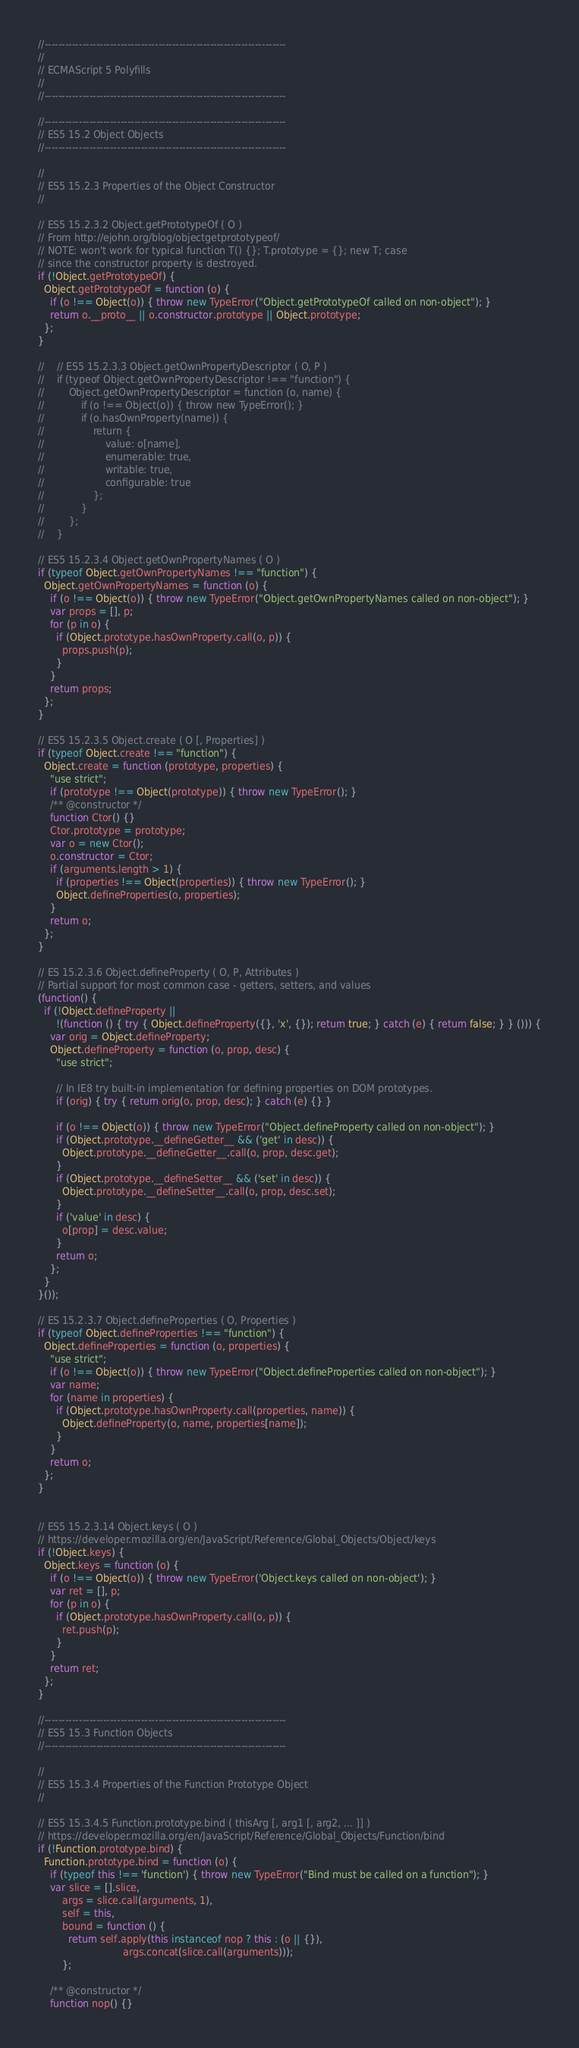Convert code to text. <code><loc_0><loc_0><loc_500><loc_500><_JavaScript_>//----------------------------------------------------------------------
//
// ECMAScript 5 Polyfills
//
//----------------------------------------------------------------------

//----------------------------------------------------------------------
// ES5 15.2 Object Objects
//----------------------------------------------------------------------

//
// ES5 15.2.3 Properties of the Object Constructor
//

// ES5 15.2.3.2 Object.getPrototypeOf ( O )
// From http://ejohn.org/blog/objectgetprototypeof/
// NOTE: won't work for typical function T() {}; T.prototype = {}; new T; case
// since the constructor property is destroyed.
if (!Object.getPrototypeOf) {
  Object.getPrototypeOf = function (o) {
    if (o !== Object(o)) { throw new TypeError("Object.getPrototypeOf called on non-object"); }
    return o.__proto__ || o.constructor.prototype || Object.prototype;
  };
}

//    // ES5 15.2.3.3 Object.getOwnPropertyDescriptor ( O, P )
//    if (typeof Object.getOwnPropertyDescriptor !== "function") {
//        Object.getOwnPropertyDescriptor = function (o, name) {
//            if (o !== Object(o)) { throw new TypeError(); }
//            if (o.hasOwnProperty(name)) {
//                return {
//                    value: o[name],
//                    enumerable: true,
//                    writable: true,
//                    configurable: true
//                };
//            }
//        };
//    }

// ES5 15.2.3.4 Object.getOwnPropertyNames ( O )
if (typeof Object.getOwnPropertyNames !== "function") {
  Object.getOwnPropertyNames = function (o) {
    if (o !== Object(o)) { throw new TypeError("Object.getOwnPropertyNames called on non-object"); }
    var props = [], p;
    for (p in o) {
      if (Object.prototype.hasOwnProperty.call(o, p)) {
        props.push(p);
      }
    }
    return props;
  };
}

// ES5 15.2.3.5 Object.create ( O [, Properties] )
if (typeof Object.create !== "function") {
  Object.create = function (prototype, properties) {
    "use strict";
    if (prototype !== Object(prototype)) { throw new TypeError(); }
    /** @constructor */
    function Ctor() {}
    Ctor.prototype = prototype;
    var o = new Ctor();
    o.constructor = Ctor;
    if (arguments.length > 1) {
      if (properties !== Object(properties)) { throw new TypeError(); }
      Object.defineProperties(o, properties);
    }
    return o;
  };
}

// ES 15.2.3.6 Object.defineProperty ( O, P, Attributes )
// Partial support for most common case - getters, setters, and values
(function() {
  if (!Object.defineProperty ||
      !(function () { try { Object.defineProperty({}, 'x', {}); return true; } catch (e) { return false; } } ())) {
    var orig = Object.defineProperty;
    Object.defineProperty = function (o, prop, desc) {
      "use strict";

      // In IE8 try built-in implementation for defining properties on DOM prototypes.
      if (orig) { try { return orig(o, prop, desc); } catch (e) {} }

      if (o !== Object(o)) { throw new TypeError("Object.defineProperty called on non-object"); }
      if (Object.prototype.__defineGetter__ && ('get' in desc)) {
        Object.prototype.__defineGetter__.call(o, prop, desc.get);
      }
      if (Object.prototype.__defineSetter__ && ('set' in desc)) {
        Object.prototype.__defineSetter__.call(o, prop, desc.set);
      }
      if ('value' in desc) {
        o[prop] = desc.value;
      }
      return o;
    };
  }
}());

// ES 15.2.3.7 Object.defineProperties ( O, Properties )
if (typeof Object.defineProperties !== "function") {
  Object.defineProperties = function (o, properties) {
    "use strict";
    if (o !== Object(o)) { throw new TypeError("Object.defineProperties called on non-object"); }
    var name;
    for (name in properties) {
      if (Object.prototype.hasOwnProperty.call(properties, name)) {
        Object.defineProperty(o, name, properties[name]);
      }
    }
    return o;
  };
}


// ES5 15.2.3.14 Object.keys ( O )
// https://developer.mozilla.org/en/JavaScript/Reference/Global_Objects/Object/keys
if (!Object.keys) {
  Object.keys = function (o) {
    if (o !== Object(o)) { throw new TypeError('Object.keys called on non-object'); }
    var ret = [], p;
    for (p in o) {
      if (Object.prototype.hasOwnProperty.call(o, p)) {
        ret.push(p);
      }
    }
    return ret;
  };
}

//----------------------------------------------------------------------
// ES5 15.3 Function Objects
//----------------------------------------------------------------------

//
// ES5 15.3.4 Properties of the Function Prototype Object
//

// ES5 15.3.4.5 Function.prototype.bind ( thisArg [, arg1 [, arg2, ... ]] )
// https://developer.mozilla.org/en/JavaScript/Reference/Global_Objects/Function/bind
if (!Function.prototype.bind) {
  Function.prototype.bind = function (o) {
    if (typeof this !== 'function') { throw new TypeError("Bind must be called on a function"); }
    var slice = [].slice,
        args = slice.call(arguments, 1),
        self = this,
        bound = function () {
          return self.apply(this instanceof nop ? this : (o || {}),
                            args.concat(slice.call(arguments)));
        };

    /** @constructor */
    function nop() {}</code> 